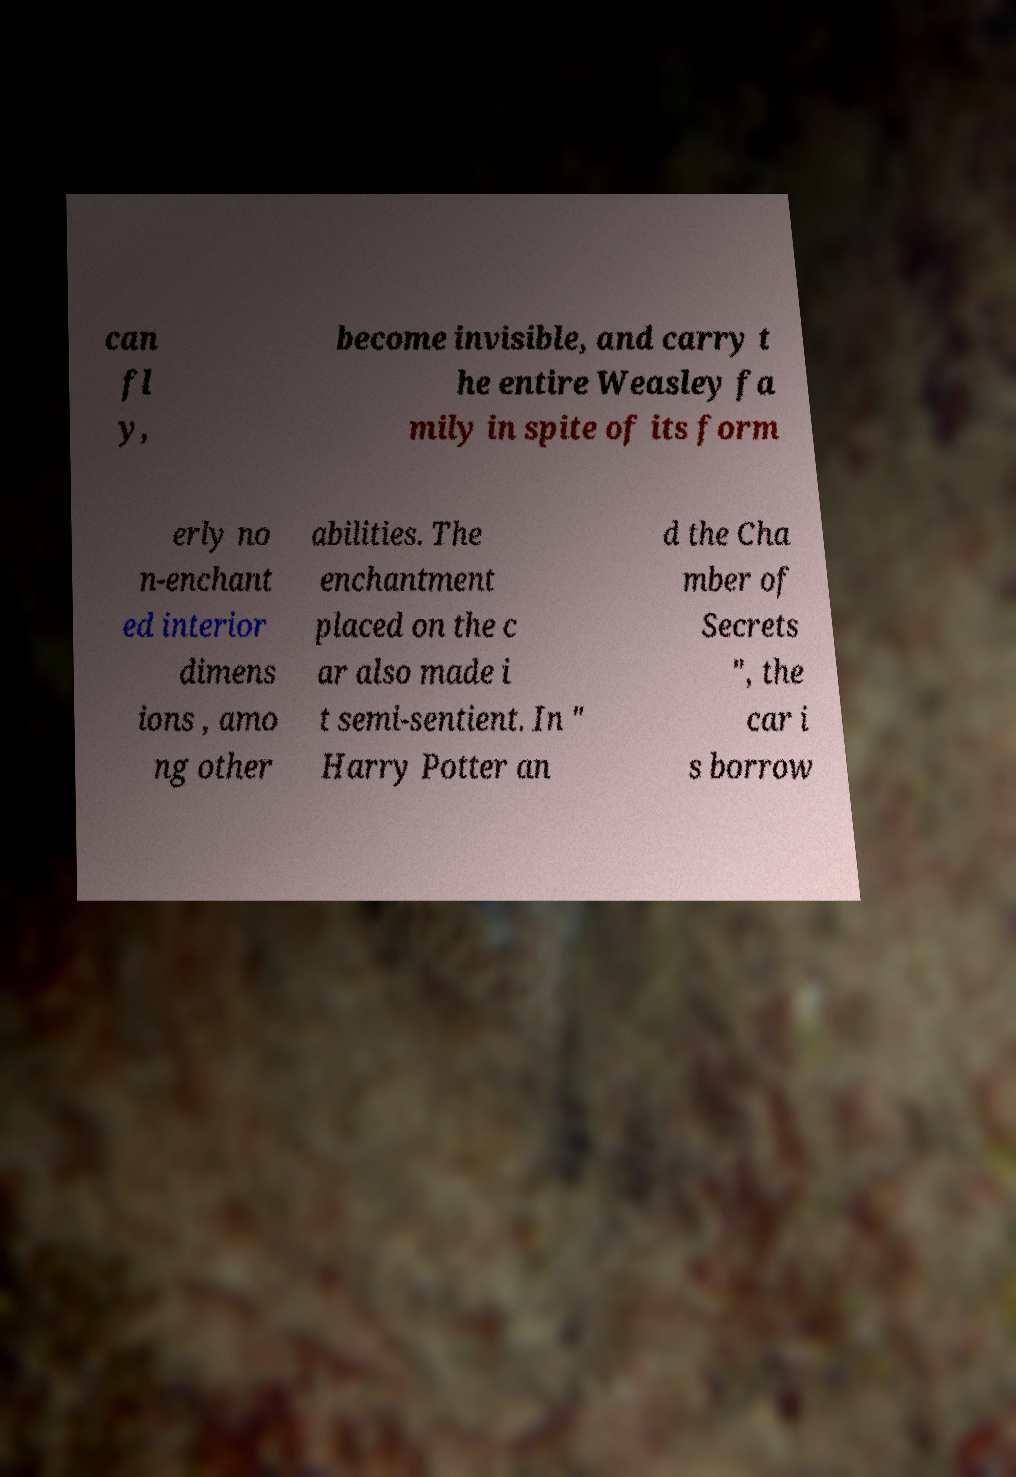Please identify and transcribe the text found in this image. can fl y, become invisible, and carry t he entire Weasley fa mily in spite of its form erly no n-enchant ed interior dimens ions , amo ng other abilities. The enchantment placed on the c ar also made i t semi-sentient. In " Harry Potter an d the Cha mber of Secrets ", the car i s borrow 